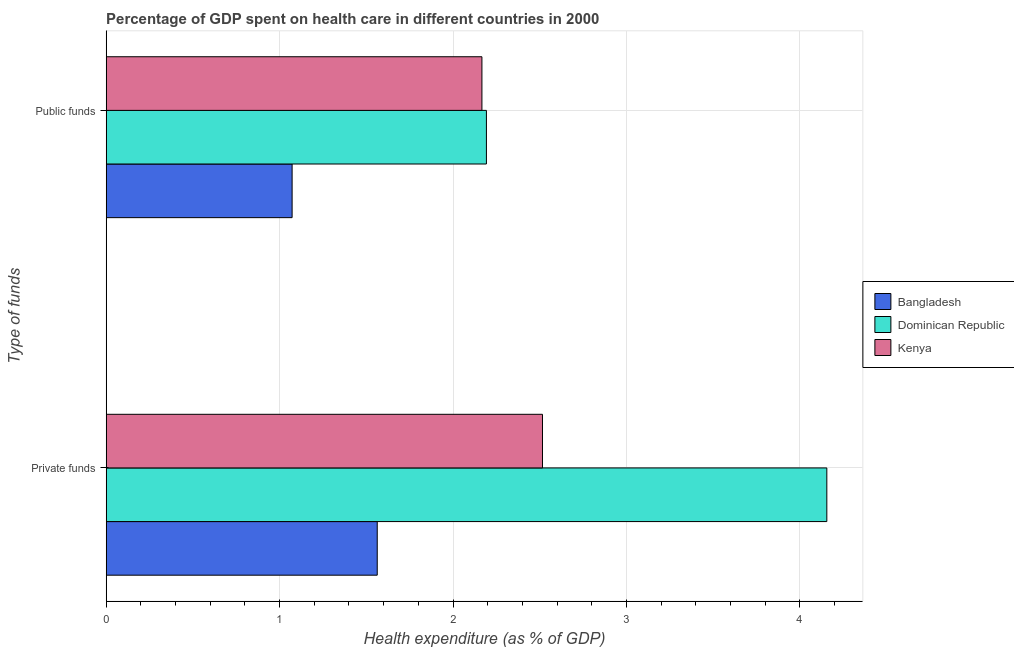How many groups of bars are there?
Offer a terse response. 2. Are the number of bars per tick equal to the number of legend labels?
Your answer should be very brief. Yes. How many bars are there on the 1st tick from the bottom?
Offer a very short reply. 3. What is the label of the 2nd group of bars from the top?
Your answer should be very brief. Private funds. What is the amount of private funds spent in healthcare in Kenya?
Provide a succinct answer. 2.52. Across all countries, what is the maximum amount of private funds spent in healthcare?
Provide a short and direct response. 4.16. Across all countries, what is the minimum amount of private funds spent in healthcare?
Provide a succinct answer. 1.56. In which country was the amount of private funds spent in healthcare maximum?
Provide a succinct answer. Dominican Republic. What is the total amount of public funds spent in healthcare in the graph?
Keep it short and to the point. 5.43. What is the difference between the amount of public funds spent in healthcare in Bangladesh and that in Dominican Republic?
Your answer should be compact. -1.12. What is the difference between the amount of public funds spent in healthcare in Kenya and the amount of private funds spent in healthcare in Dominican Republic?
Give a very brief answer. -1.99. What is the average amount of public funds spent in healthcare per country?
Provide a short and direct response. 1.81. What is the difference between the amount of public funds spent in healthcare and amount of private funds spent in healthcare in Bangladesh?
Keep it short and to the point. -0.49. In how many countries, is the amount of public funds spent in healthcare greater than 3.4 %?
Give a very brief answer. 0. What is the ratio of the amount of public funds spent in healthcare in Kenya to that in Dominican Republic?
Your answer should be very brief. 0.99. Is the amount of private funds spent in healthcare in Dominican Republic less than that in Bangladesh?
Keep it short and to the point. No. In how many countries, is the amount of private funds spent in healthcare greater than the average amount of private funds spent in healthcare taken over all countries?
Offer a very short reply. 1. What does the 1st bar from the top in Public funds represents?
Your answer should be very brief. Kenya. What does the 2nd bar from the bottom in Private funds represents?
Your response must be concise. Dominican Republic. What is the difference between two consecutive major ticks on the X-axis?
Provide a succinct answer. 1. Are the values on the major ticks of X-axis written in scientific E-notation?
Offer a very short reply. No. How many legend labels are there?
Ensure brevity in your answer.  3. What is the title of the graph?
Provide a succinct answer. Percentage of GDP spent on health care in different countries in 2000. What is the label or title of the X-axis?
Your answer should be very brief. Health expenditure (as % of GDP). What is the label or title of the Y-axis?
Make the answer very short. Type of funds. What is the Health expenditure (as % of GDP) in Bangladesh in Private funds?
Your answer should be compact. 1.56. What is the Health expenditure (as % of GDP) in Dominican Republic in Private funds?
Your answer should be very brief. 4.16. What is the Health expenditure (as % of GDP) in Kenya in Private funds?
Keep it short and to the point. 2.52. What is the Health expenditure (as % of GDP) in Bangladesh in Public funds?
Your answer should be compact. 1.07. What is the Health expenditure (as % of GDP) of Dominican Republic in Public funds?
Your answer should be compact. 2.19. What is the Health expenditure (as % of GDP) in Kenya in Public funds?
Offer a terse response. 2.17. Across all Type of funds, what is the maximum Health expenditure (as % of GDP) in Bangladesh?
Your response must be concise. 1.56. Across all Type of funds, what is the maximum Health expenditure (as % of GDP) in Dominican Republic?
Ensure brevity in your answer.  4.16. Across all Type of funds, what is the maximum Health expenditure (as % of GDP) in Kenya?
Your answer should be very brief. 2.52. Across all Type of funds, what is the minimum Health expenditure (as % of GDP) of Bangladesh?
Your response must be concise. 1.07. Across all Type of funds, what is the minimum Health expenditure (as % of GDP) of Dominican Republic?
Your answer should be compact. 2.19. Across all Type of funds, what is the minimum Health expenditure (as % of GDP) of Kenya?
Your answer should be compact. 2.17. What is the total Health expenditure (as % of GDP) of Bangladesh in the graph?
Give a very brief answer. 2.64. What is the total Health expenditure (as % of GDP) of Dominican Republic in the graph?
Your response must be concise. 6.35. What is the total Health expenditure (as % of GDP) of Kenya in the graph?
Provide a short and direct response. 4.68. What is the difference between the Health expenditure (as % of GDP) in Bangladesh in Private funds and that in Public funds?
Provide a succinct answer. 0.49. What is the difference between the Health expenditure (as % of GDP) of Dominican Republic in Private funds and that in Public funds?
Make the answer very short. 1.96. What is the difference between the Health expenditure (as % of GDP) of Kenya in Private funds and that in Public funds?
Make the answer very short. 0.35. What is the difference between the Health expenditure (as % of GDP) in Bangladesh in Private funds and the Health expenditure (as % of GDP) in Dominican Republic in Public funds?
Give a very brief answer. -0.63. What is the difference between the Health expenditure (as % of GDP) of Bangladesh in Private funds and the Health expenditure (as % of GDP) of Kenya in Public funds?
Offer a very short reply. -0.6. What is the difference between the Health expenditure (as % of GDP) in Dominican Republic in Private funds and the Health expenditure (as % of GDP) in Kenya in Public funds?
Provide a short and direct response. 1.99. What is the average Health expenditure (as % of GDP) of Bangladesh per Type of funds?
Your answer should be very brief. 1.32. What is the average Health expenditure (as % of GDP) in Dominican Republic per Type of funds?
Offer a terse response. 3.17. What is the average Health expenditure (as % of GDP) of Kenya per Type of funds?
Give a very brief answer. 2.34. What is the difference between the Health expenditure (as % of GDP) in Bangladesh and Health expenditure (as % of GDP) in Dominican Republic in Private funds?
Offer a very short reply. -2.59. What is the difference between the Health expenditure (as % of GDP) of Bangladesh and Health expenditure (as % of GDP) of Kenya in Private funds?
Give a very brief answer. -0.95. What is the difference between the Health expenditure (as % of GDP) in Dominican Republic and Health expenditure (as % of GDP) in Kenya in Private funds?
Provide a short and direct response. 1.64. What is the difference between the Health expenditure (as % of GDP) in Bangladesh and Health expenditure (as % of GDP) in Dominican Republic in Public funds?
Offer a very short reply. -1.12. What is the difference between the Health expenditure (as % of GDP) of Bangladesh and Health expenditure (as % of GDP) of Kenya in Public funds?
Your response must be concise. -1.09. What is the difference between the Health expenditure (as % of GDP) in Dominican Republic and Health expenditure (as % of GDP) in Kenya in Public funds?
Make the answer very short. 0.03. What is the ratio of the Health expenditure (as % of GDP) in Bangladesh in Private funds to that in Public funds?
Offer a terse response. 1.46. What is the ratio of the Health expenditure (as % of GDP) of Dominican Republic in Private funds to that in Public funds?
Ensure brevity in your answer.  1.9. What is the ratio of the Health expenditure (as % of GDP) in Kenya in Private funds to that in Public funds?
Your answer should be compact. 1.16. What is the difference between the highest and the second highest Health expenditure (as % of GDP) in Bangladesh?
Offer a terse response. 0.49. What is the difference between the highest and the second highest Health expenditure (as % of GDP) in Dominican Republic?
Give a very brief answer. 1.96. What is the difference between the highest and the second highest Health expenditure (as % of GDP) of Kenya?
Your answer should be very brief. 0.35. What is the difference between the highest and the lowest Health expenditure (as % of GDP) in Bangladesh?
Your response must be concise. 0.49. What is the difference between the highest and the lowest Health expenditure (as % of GDP) of Dominican Republic?
Keep it short and to the point. 1.96. What is the difference between the highest and the lowest Health expenditure (as % of GDP) in Kenya?
Keep it short and to the point. 0.35. 